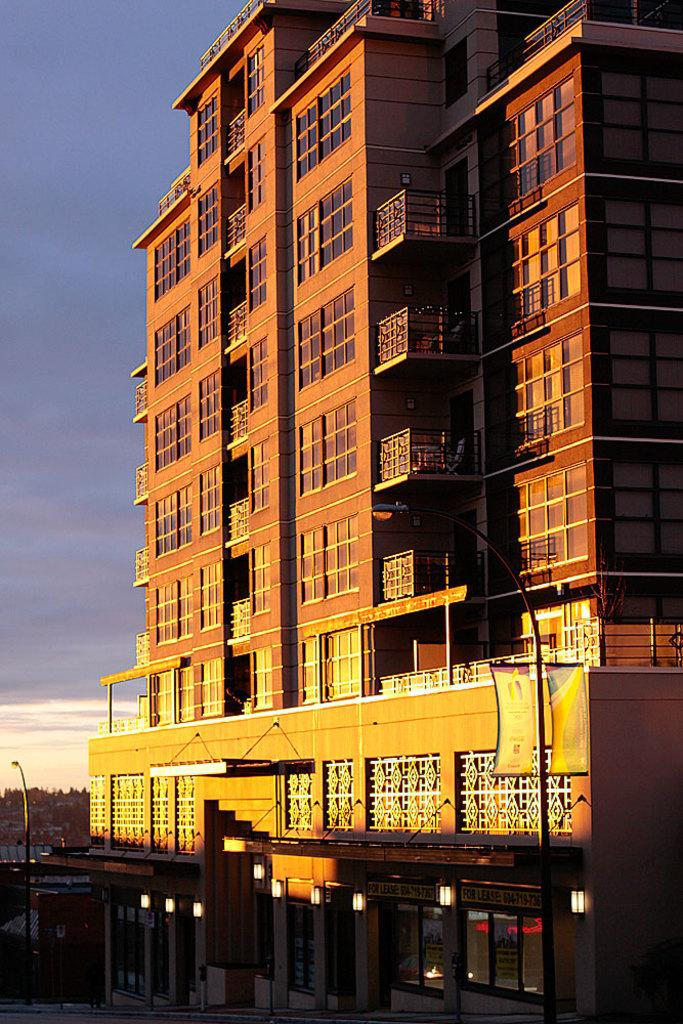What is the main structure in the image? There is a big building in the image. How is the sky depicted on the left side of the image? The sky on the left side of the image is cloudy. What type of beef is being prepared by the army in the image? There is no beef, army, or any cooking activity present in the image. 